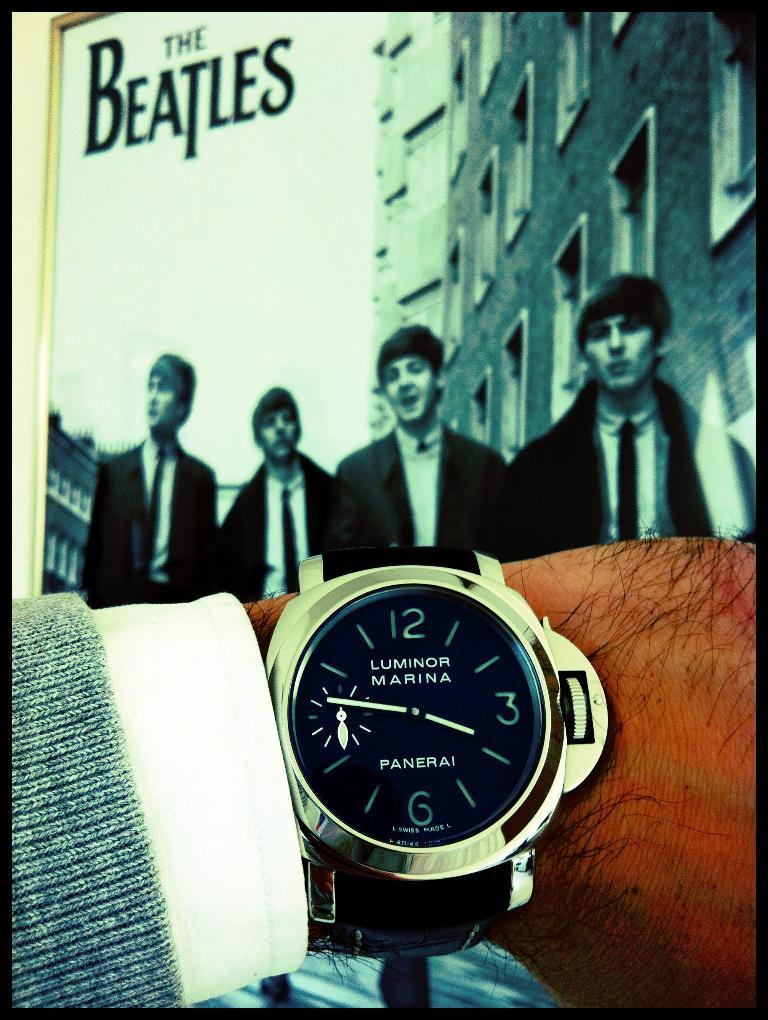<image>
Write a terse but informative summary of the picture. A man wearing a watch, that says Panerai on it. 